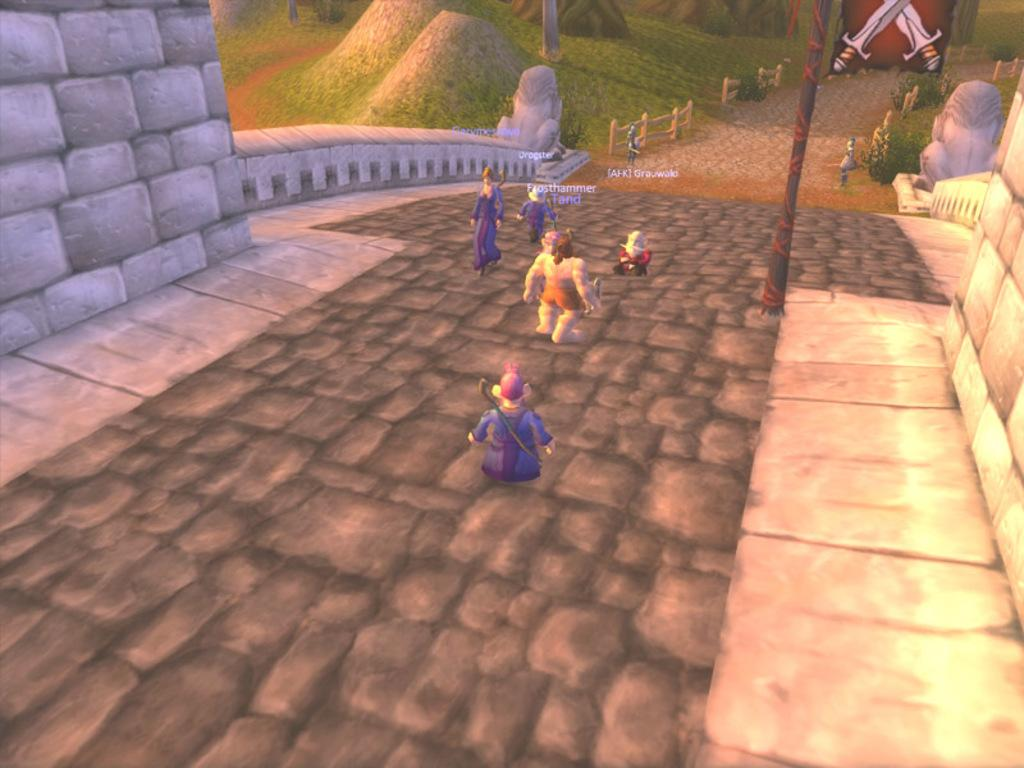What type of images are present in the foreground of the image? There are cartoons in the image. What can be seen in the background of the image? In the background of the image, there are statues, seats or chairs, a wall, plants, and a fence. Can you describe the setting of the image? The image features cartoons in the foreground and a background with various elements, including statues, seats or chairs, a wall, plants, and a fence. How many ladybugs can be seen crawling on the cartoons in the image? There are no ladybugs present in the image; it features cartoons and various elements in the background. What type of operation is being performed on the statues in the background of the image? There is no operation being performed on the statues in the image; they are simply part of the background setting. 